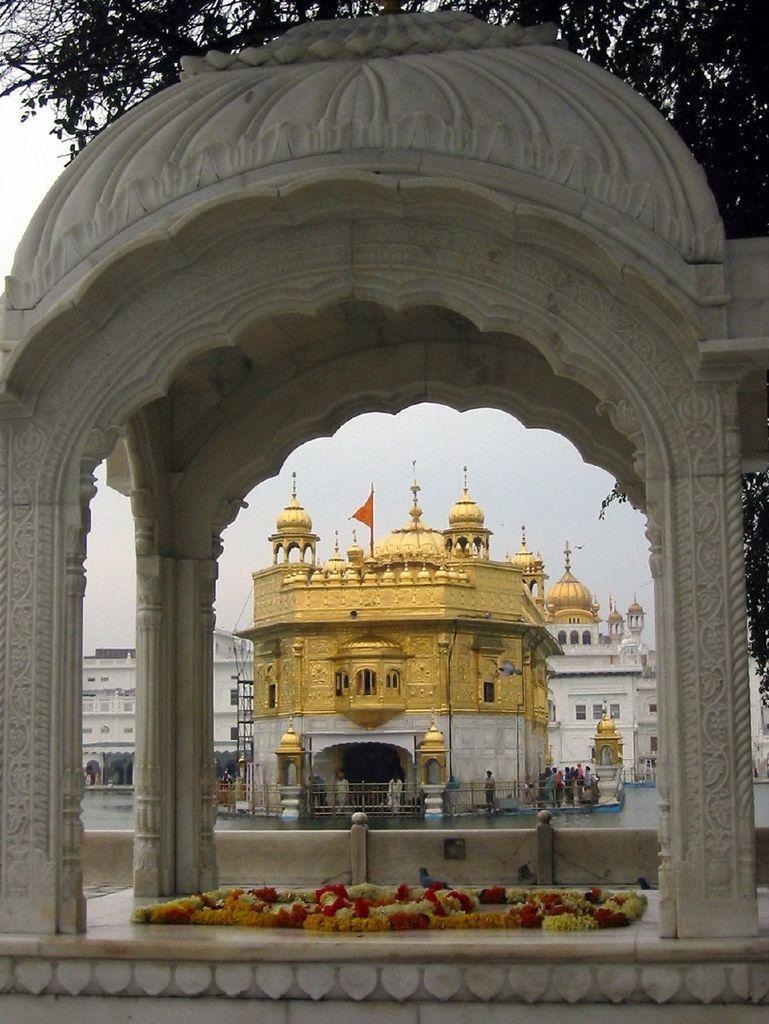In one or two sentences, can you explain what this image depicts? In this image we can see buildings, water body, flowers and the sky. There is a tree at the top of the image. 